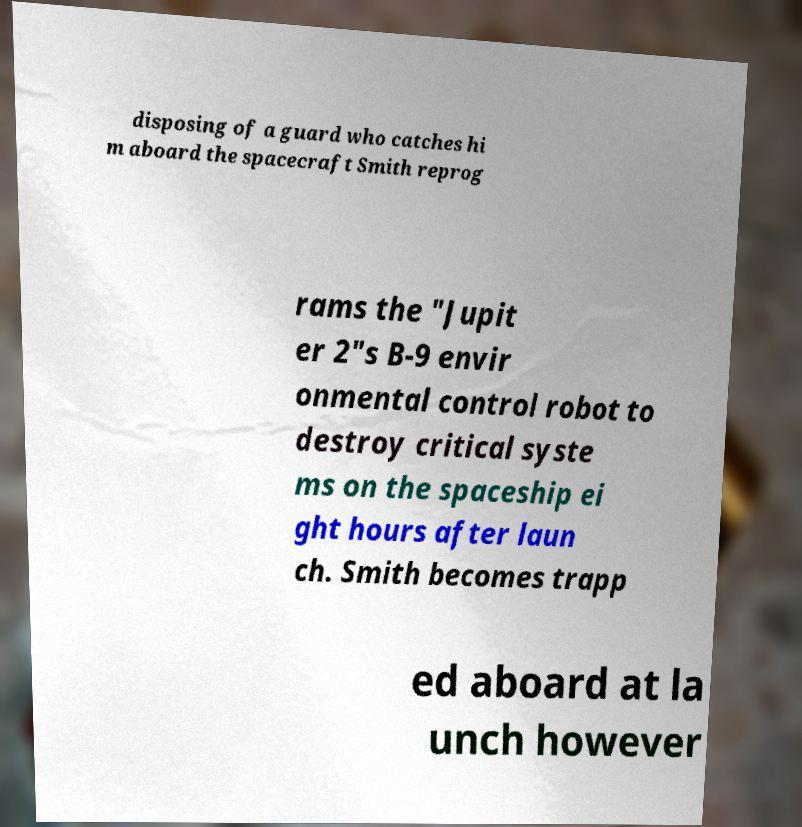For documentation purposes, I need the text within this image transcribed. Could you provide that? disposing of a guard who catches hi m aboard the spacecraft Smith reprog rams the "Jupit er 2"s B-9 envir onmental control robot to destroy critical syste ms on the spaceship ei ght hours after laun ch. Smith becomes trapp ed aboard at la unch however 